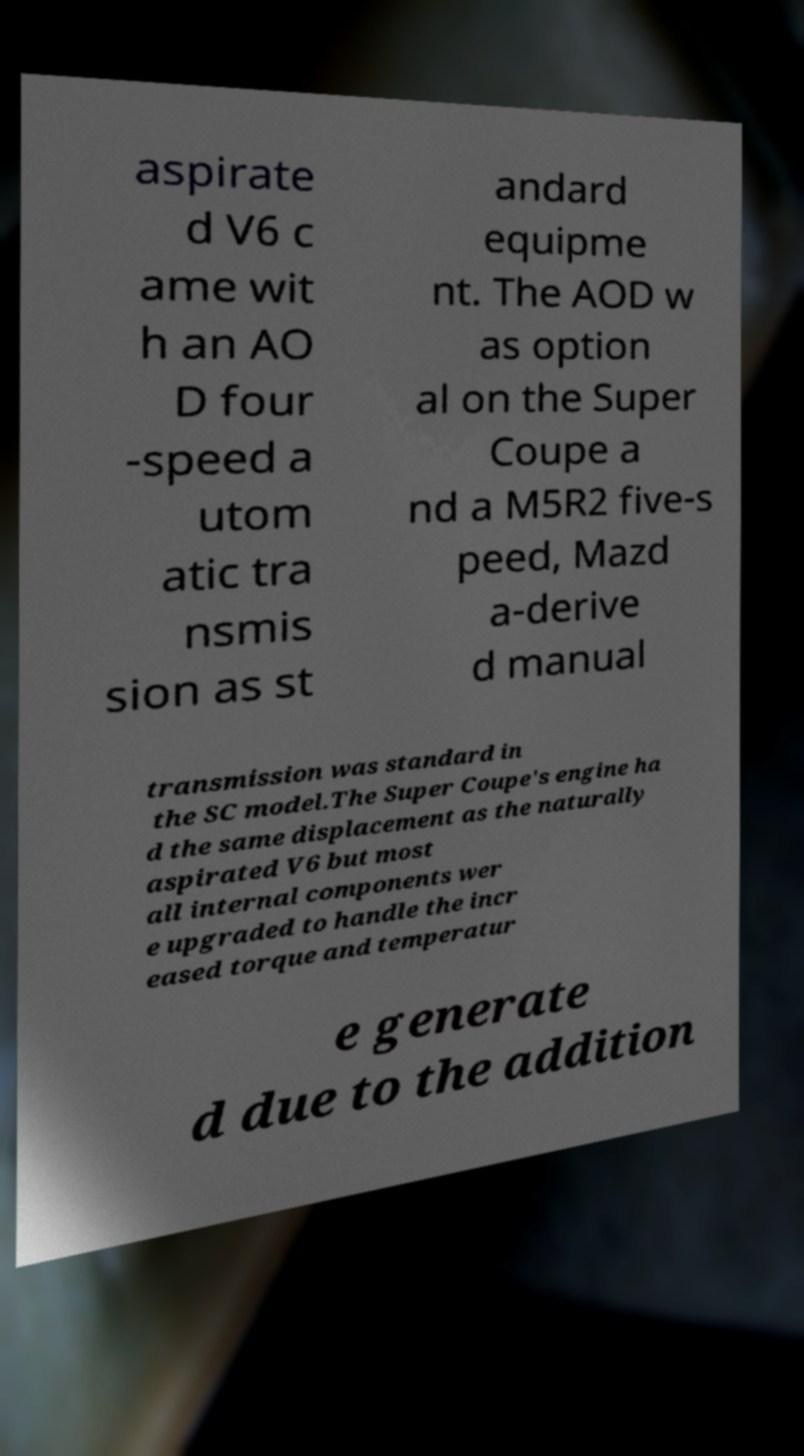Could you extract and type out the text from this image? aspirate d V6 c ame wit h an AO D four -speed a utom atic tra nsmis sion as st andard equipme nt. The AOD w as option al on the Super Coupe a nd a M5R2 five-s peed, Mazd a-derive d manual transmission was standard in the SC model.The Super Coupe's engine ha d the same displacement as the naturally aspirated V6 but most all internal components wer e upgraded to handle the incr eased torque and temperatur e generate d due to the addition 